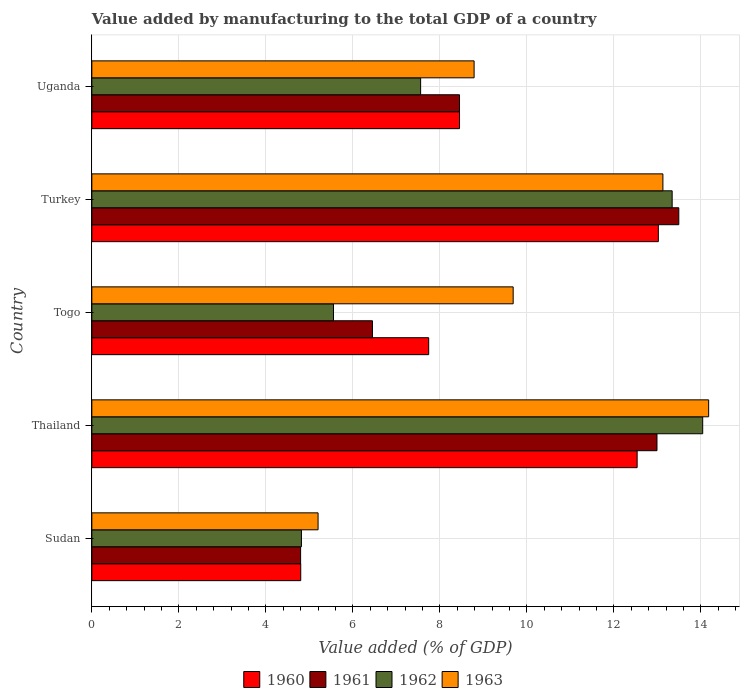How many different coloured bars are there?
Provide a succinct answer. 4. Are the number of bars per tick equal to the number of legend labels?
Your response must be concise. Yes. Are the number of bars on each tick of the Y-axis equal?
Give a very brief answer. Yes. How many bars are there on the 4th tick from the bottom?
Keep it short and to the point. 4. What is the label of the 3rd group of bars from the top?
Provide a succinct answer. Togo. In how many cases, is the number of bars for a given country not equal to the number of legend labels?
Your answer should be very brief. 0. What is the value added by manufacturing to the total GDP in 1962 in Thailand?
Your response must be concise. 14.04. Across all countries, what is the maximum value added by manufacturing to the total GDP in 1962?
Offer a very short reply. 14.04. Across all countries, what is the minimum value added by manufacturing to the total GDP in 1963?
Provide a short and direct response. 5.2. In which country was the value added by manufacturing to the total GDP in 1961 maximum?
Your answer should be very brief. Turkey. In which country was the value added by manufacturing to the total GDP in 1963 minimum?
Provide a short and direct response. Sudan. What is the total value added by manufacturing to the total GDP in 1960 in the graph?
Your response must be concise. 46.56. What is the difference between the value added by manufacturing to the total GDP in 1963 in Turkey and that in Uganda?
Provide a short and direct response. 4.34. What is the difference between the value added by manufacturing to the total GDP in 1962 in Turkey and the value added by manufacturing to the total GDP in 1963 in Uganda?
Your answer should be compact. 4.55. What is the average value added by manufacturing to the total GDP in 1963 per country?
Give a very brief answer. 10.2. What is the difference between the value added by manufacturing to the total GDP in 1961 and value added by manufacturing to the total GDP in 1963 in Thailand?
Keep it short and to the point. -1.19. In how many countries, is the value added by manufacturing to the total GDP in 1960 greater than 8 %?
Give a very brief answer. 3. What is the ratio of the value added by manufacturing to the total GDP in 1960 in Sudan to that in Uganda?
Ensure brevity in your answer.  0.57. Is the difference between the value added by manufacturing to the total GDP in 1961 in Sudan and Turkey greater than the difference between the value added by manufacturing to the total GDP in 1963 in Sudan and Turkey?
Give a very brief answer. No. What is the difference between the highest and the second highest value added by manufacturing to the total GDP in 1963?
Your answer should be very brief. 1.05. What is the difference between the highest and the lowest value added by manufacturing to the total GDP in 1963?
Provide a succinct answer. 8.98. Is it the case that in every country, the sum of the value added by manufacturing to the total GDP in 1960 and value added by manufacturing to the total GDP in 1963 is greater than the value added by manufacturing to the total GDP in 1962?
Offer a very short reply. Yes. Does the graph contain any zero values?
Ensure brevity in your answer.  No. Does the graph contain grids?
Make the answer very short. Yes. How are the legend labels stacked?
Offer a very short reply. Horizontal. What is the title of the graph?
Provide a succinct answer. Value added by manufacturing to the total GDP of a country. What is the label or title of the X-axis?
Your answer should be very brief. Value added (% of GDP). What is the Value added (% of GDP) in 1960 in Sudan?
Keep it short and to the point. 4.8. What is the Value added (% of GDP) in 1961 in Sudan?
Give a very brief answer. 4.8. What is the Value added (% of GDP) of 1962 in Sudan?
Give a very brief answer. 4.82. What is the Value added (% of GDP) of 1963 in Sudan?
Your response must be concise. 5.2. What is the Value added (% of GDP) in 1960 in Thailand?
Your answer should be compact. 12.54. What is the Value added (% of GDP) in 1961 in Thailand?
Give a very brief answer. 12.99. What is the Value added (% of GDP) of 1962 in Thailand?
Give a very brief answer. 14.04. What is the Value added (% of GDP) in 1963 in Thailand?
Keep it short and to the point. 14.18. What is the Value added (% of GDP) of 1960 in Togo?
Offer a terse response. 7.74. What is the Value added (% of GDP) in 1961 in Togo?
Provide a succinct answer. 6.45. What is the Value added (% of GDP) in 1962 in Togo?
Your response must be concise. 5.56. What is the Value added (% of GDP) in 1963 in Togo?
Your answer should be very brief. 9.69. What is the Value added (% of GDP) in 1960 in Turkey?
Offer a very short reply. 13.02. What is the Value added (% of GDP) in 1961 in Turkey?
Your answer should be very brief. 13.49. What is the Value added (% of GDP) in 1962 in Turkey?
Keep it short and to the point. 13.34. What is the Value added (% of GDP) in 1963 in Turkey?
Provide a succinct answer. 13.13. What is the Value added (% of GDP) in 1960 in Uganda?
Provide a short and direct response. 8.45. What is the Value added (% of GDP) of 1961 in Uganda?
Your response must be concise. 8.45. What is the Value added (% of GDP) in 1962 in Uganda?
Ensure brevity in your answer.  7.56. What is the Value added (% of GDP) of 1963 in Uganda?
Keep it short and to the point. 8.79. Across all countries, what is the maximum Value added (% of GDP) of 1960?
Offer a terse response. 13.02. Across all countries, what is the maximum Value added (% of GDP) of 1961?
Keep it short and to the point. 13.49. Across all countries, what is the maximum Value added (% of GDP) in 1962?
Give a very brief answer. 14.04. Across all countries, what is the maximum Value added (% of GDP) of 1963?
Provide a short and direct response. 14.18. Across all countries, what is the minimum Value added (% of GDP) of 1960?
Your response must be concise. 4.8. Across all countries, what is the minimum Value added (% of GDP) in 1961?
Keep it short and to the point. 4.8. Across all countries, what is the minimum Value added (% of GDP) of 1962?
Provide a short and direct response. 4.82. Across all countries, what is the minimum Value added (% of GDP) in 1963?
Offer a terse response. 5.2. What is the total Value added (% of GDP) in 1960 in the graph?
Keep it short and to the point. 46.56. What is the total Value added (% of GDP) of 1961 in the graph?
Your answer should be very brief. 46.19. What is the total Value added (% of GDP) of 1962 in the graph?
Your answer should be very brief. 45.32. What is the total Value added (% of GDP) of 1963 in the graph?
Your answer should be very brief. 50.99. What is the difference between the Value added (% of GDP) in 1960 in Sudan and that in Thailand?
Ensure brevity in your answer.  -7.73. What is the difference between the Value added (% of GDP) in 1961 in Sudan and that in Thailand?
Provide a succinct answer. -8.19. What is the difference between the Value added (% of GDP) in 1962 in Sudan and that in Thailand?
Make the answer very short. -9.23. What is the difference between the Value added (% of GDP) of 1963 in Sudan and that in Thailand?
Make the answer very short. -8.98. What is the difference between the Value added (% of GDP) of 1960 in Sudan and that in Togo?
Provide a short and direct response. -2.94. What is the difference between the Value added (% of GDP) in 1961 in Sudan and that in Togo?
Provide a succinct answer. -1.65. What is the difference between the Value added (% of GDP) of 1962 in Sudan and that in Togo?
Ensure brevity in your answer.  -0.74. What is the difference between the Value added (% of GDP) of 1963 in Sudan and that in Togo?
Offer a terse response. -4.49. What is the difference between the Value added (% of GDP) in 1960 in Sudan and that in Turkey?
Offer a terse response. -8.22. What is the difference between the Value added (% of GDP) of 1961 in Sudan and that in Turkey?
Your response must be concise. -8.69. What is the difference between the Value added (% of GDP) of 1962 in Sudan and that in Turkey?
Provide a short and direct response. -8.52. What is the difference between the Value added (% of GDP) in 1963 in Sudan and that in Turkey?
Provide a succinct answer. -7.93. What is the difference between the Value added (% of GDP) of 1960 in Sudan and that in Uganda?
Your response must be concise. -3.65. What is the difference between the Value added (% of GDP) of 1961 in Sudan and that in Uganda?
Give a very brief answer. -3.65. What is the difference between the Value added (% of GDP) of 1962 in Sudan and that in Uganda?
Offer a terse response. -2.74. What is the difference between the Value added (% of GDP) of 1963 in Sudan and that in Uganda?
Offer a terse response. -3.59. What is the difference between the Value added (% of GDP) of 1960 in Thailand and that in Togo?
Make the answer very short. 4.79. What is the difference between the Value added (% of GDP) in 1961 in Thailand and that in Togo?
Offer a very short reply. 6.54. What is the difference between the Value added (% of GDP) in 1962 in Thailand and that in Togo?
Ensure brevity in your answer.  8.49. What is the difference between the Value added (% of GDP) of 1963 in Thailand and that in Togo?
Your answer should be compact. 4.49. What is the difference between the Value added (% of GDP) in 1960 in Thailand and that in Turkey?
Your response must be concise. -0.49. What is the difference between the Value added (% of GDP) of 1961 in Thailand and that in Turkey?
Provide a succinct answer. -0.5. What is the difference between the Value added (% of GDP) in 1962 in Thailand and that in Turkey?
Give a very brief answer. 0.7. What is the difference between the Value added (% of GDP) in 1963 in Thailand and that in Turkey?
Provide a succinct answer. 1.05. What is the difference between the Value added (% of GDP) of 1960 in Thailand and that in Uganda?
Give a very brief answer. 4.08. What is the difference between the Value added (% of GDP) of 1961 in Thailand and that in Uganda?
Provide a succinct answer. 4.54. What is the difference between the Value added (% of GDP) of 1962 in Thailand and that in Uganda?
Keep it short and to the point. 6.49. What is the difference between the Value added (% of GDP) of 1963 in Thailand and that in Uganda?
Offer a very short reply. 5.39. What is the difference between the Value added (% of GDP) of 1960 in Togo and that in Turkey?
Your answer should be very brief. -5.28. What is the difference between the Value added (% of GDP) of 1961 in Togo and that in Turkey?
Offer a terse response. -7.04. What is the difference between the Value added (% of GDP) of 1962 in Togo and that in Turkey?
Your response must be concise. -7.79. What is the difference between the Value added (% of GDP) of 1963 in Togo and that in Turkey?
Your answer should be very brief. -3.44. What is the difference between the Value added (% of GDP) in 1960 in Togo and that in Uganda?
Make the answer very short. -0.71. What is the difference between the Value added (% of GDP) of 1961 in Togo and that in Uganda?
Offer a terse response. -2. What is the difference between the Value added (% of GDP) of 1962 in Togo and that in Uganda?
Keep it short and to the point. -2. What is the difference between the Value added (% of GDP) in 1963 in Togo and that in Uganda?
Your answer should be compact. 0.9. What is the difference between the Value added (% of GDP) of 1960 in Turkey and that in Uganda?
Keep it short and to the point. 4.57. What is the difference between the Value added (% of GDP) of 1961 in Turkey and that in Uganda?
Your answer should be compact. 5.04. What is the difference between the Value added (% of GDP) of 1962 in Turkey and that in Uganda?
Ensure brevity in your answer.  5.78. What is the difference between the Value added (% of GDP) in 1963 in Turkey and that in Uganda?
Provide a succinct answer. 4.34. What is the difference between the Value added (% of GDP) of 1960 in Sudan and the Value added (% of GDP) of 1961 in Thailand?
Offer a terse response. -8.19. What is the difference between the Value added (% of GDP) in 1960 in Sudan and the Value added (% of GDP) in 1962 in Thailand?
Offer a very short reply. -9.24. What is the difference between the Value added (% of GDP) in 1960 in Sudan and the Value added (% of GDP) in 1963 in Thailand?
Offer a very short reply. -9.38. What is the difference between the Value added (% of GDP) in 1961 in Sudan and the Value added (% of GDP) in 1962 in Thailand?
Provide a succinct answer. -9.24. What is the difference between the Value added (% of GDP) of 1961 in Sudan and the Value added (% of GDP) of 1963 in Thailand?
Provide a short and direct response. -9.38. What is the difference between the Value added (% of GDP) in 1962 in Sudan and the Value added (% of GDP) in 1963 in Thailand?
Make the answer very short. -9.36. What is the difference between the Value added (% of GDP) in 1960 in Sudan and the Value added (% of GDP) in 1961 in Togo?
Give a very brief answer. -1.65. What is the difference between the Value added (% of GDP) of 1960 in Sudan and the Value added (% of GDP) of 1962 in Togo?
Your response must be concise. -0.75. What is the difference between the Value added (% of GDP) in 1960 in Sudan and the Value added (% of GDP) in 1963 in Togo?
Provide a succinct answer. -4.88. What is the difference between the Value added (% of GDP) of 1961 in Sudan and the Value added (% of GDP) of 1962 in Togo?
Offer a very short reply. -0.76. What is the difference between the Value added (% of GDP) of 1961 in Sudan and the Value added (% of GDP) of 1963 in Togo?
Give a very brief answer. -4.89. What is the difference between the Value added (% of GDP) of 1962 in Sudan and the Value added (% of GDP) of 1963 in Togo?
Ensure brevity in your answer.  -4.87. What is the difference between the Value added (% of GDP) of 1960 in Sudan and the Value added (% of GDP) of 1961 in Turkey?
Your response must be concise. -8.69. What is the difference between the Value added (% of GDP) of 1960 in Sudan and the Value added (% of GDP) of 1962 in Turkey?
Ensure brevity in your answer.  -8.54. What is the difference between the Value added (% of GDP) in 1960 in Sudan and the Value added (% of GDP) in 1963 in Turkey?
Make the answer very short. -8.33. What is the difference between the Value added (% of GDP) of 1961 in Sudan and the Value added (% of GDP) of 1962 in Turkey?
Your response must be concise. -8.54. What is the difference between the Value added (% of GDP) in 1961 in Sudan and the Value added (% of GDP) in 1963 in Turkey?
Make the answer very short. -8.33. What is the difference between the Value added (% of GDP) of 1962 in Sudan and the Value added (% of GDP) of 1963 in Turkey?
Your answer should be compact. -8.31. What is the difference between the Value added (% of GDP) of 1960 in Sudan and the Value added (% of GDP) of 1961 in Uganda?
Give a very brief answer. -3.65. What is the difference between the Value added (% of GDP) in 1960 in Sudan and the Value added (% of GDP) in 1962 in Uganda?
Offer a very short reply. -2.76. What is the difference between the Value added (% of GDP) in 1960 in Sudan and the Value added (% of GDP) in 1963 in Uganda?
Your answer should be compact. -3.99. What is the difference between the Value added (% of GDP) of 1961 in Sudan and the Value added (% of GDP) of 1962 in Uganda?
Offer a very short reply. -2.76. What is the difference between the Value added (% of GDP) of 1961 in Sudan and the Value added (% of GDP) of 1963 in Uganda?
Make the answer very short. -3.99. What is the difference between the Value added (% of GDP) of 1962 in Sudan and the Value added (% of GDP) of 1963 in Uganda?
Provide a short and direct response. -3.97. What is the difference between the Value added (% of GDP) of 1960 in Thailand and the Value added (% of GDP) of 1961 in Togo?
Provide a short and direct response. 6.09. What is the difference between the Value added (% of GDP) in 1960 in Thailand and the Value added (% of GDP) in 1962 in Togo?
Provide a short and direct response. 6.98. What is the difference between the Value added (% of GDP) of 1960 in Thailand and the Value added (% of GDP) of 1963 in Togo?
Ensure brevity in your answer.  2.85. What is the difference between the Value added (% of GDP) in 1961 in Thailand and the Value added (% of GDP) in 1962 in Togo?
Offer a terse response. 7.44. What is the difference between the Value added (% of GDP) of 1961 in Thailand and the Value added (% of GDP) of 1963 in Togo?
Ensure brevity in your answer.  3.31. What is the difference between the Value added (% of GDP) in 1962 in Thailand and the Value added (% of GDP) in 1963 in Togo?
Offer a very short reply. 4.36. What is the difference between the Value added (% of GDP) in 1960 in Thailand and the Value added (% of GDP) in 1961 in Turkey?
Offer a very short reply. -0.96. What is the difference between the Value added (% of GDP) of 1960 in Thailand and the Value added (% of GDP) of 1962 in Turkey?
Provide a succinct answer. -0.81. What is the difference between the Value added (% of GDP) in 1960 in Thailand and the Value added (% of GDP) in 1963 in Turkey?
Provide a succinct answer. -0.59. What is the difference between the Value added (% of GDP) in 1961 in Thailand and the Value added (% of GDP) in 1962 in Turkey?
Keep it short and to the point. -0.35. What is the difference between the Value added (% of GDP) of 1961 in Thailand and the Value added (% of GDP) of 1963 in Turkey?
Make the answer very short. -0.14. What is the difference between the Value added (% of GDP) in 1962 in Thailand and the Value added (% of GDP) in 1963 in Turkey?
Offer a very short reply. 0.92. What is the difference between the Value added (% of GDP) of 1960 in Thailand and the Value added (% of GDP) of 1961 in Uganda?
Make the answer very short. 4.08. What is the difference between the Value added (% of GDP) of 1960 in Thailand and the Value added (% of GDP) of 1962 in Uganda?
Keep it short and to the point. 4.98. What is the difference between the Value added (% of GDP) of 1960 in Thailand and the Value added (% of GDP) of 1963 in Uganda?
Provide a short and direct response. 3.75. What is the difference between the Value added (% of GDP) of 1961 in Thailand and the Value added (% of GDP) of 1962 in Uganda?
Offer a terse response. 5.43. What is the difference between the Value added (% of GDP) in 1961 in Thailand and the Value added (% of GDP) in 1963 in Uganda?
Give a very brief answer. 4.2. What is the difference between the Value added (% of GDP) of 1962 in Thailand and the Value added (% of GDP) of 1963 in Uganda?
Your answer should be compact. 5.26. What is the difference between the Value added (% of GDP) of 1960 in Togo and the Value added (% of GDP) of 1961 in Turkey?
Provide a succinct answer. -5.75. What is the difference between the Value added (% of GDP) in 1960 in Togo and the Value added (% of GDP) in 1962 in Turkey?
Offer a very short reply. -5.6. What is the difference between the Value added (% of GDP) of 1960 in Togo and the Value added (% of GDP) of 1963 in Turkey?
Give a very brief answer. -5.38. What is the difference between the Value added (% of GDP) of 1961 in Togo and the Value added (% of GDP) of 1962 in Turkey?
Offer a very short reply. -6.89. What is the difference between the Value added (% of GDP) in 1961 in Togo and the Value added (% of GDP) in 1963 in Turkey?
Provide a short and direct response. -6.68. What is the difference between the Value added (% of GDP) of 1962 in Togo and the Value added (% of GDP) of 1963 in Turkey?
Keep it short and to the point. -7.57. What is the difference between the Value added (% of GDP) in 1960 in Togo and the Value added (% of GDP) in 1961 in Uganda?
Your answer should be very brief. -0.71. What is the difference between the Value added (% of GDP) of 1960 in Togo and the Value added (% of GDP) of 1962 in Uganda?
Your response must be concise. 0.19. What is the difference between the Value added (% of GDP) of 1960 in Togo and the Value added (% of GDP) of 1963 in Uganda?
Ensure brevity in your answer.  -1.04. What is the difference between the Value added (% of GDP) of 1961 in Togo and the Value added (% of GDP) of 1962 in Uganda?
Give a very brief answer. -1.11. What is the difference between the Value added (% of GDP) of 1961 in Togo and the Value added (% of GDP) of 1963 in Uganda?
Provide a short and direct response. -2.34. What is the difference between the Value added (% of GDP) of 1962 in Togo and the Value added (% of GDP) of 1963 in Uganda?
Make the answer very short. -3.23. What is the difference between the Value added (% of GDP) in 1960 in Turkey and the Value added (% of GDP) in 1961 in Uganda?
Your response must be concise. 4.57. What is the difference between the Value added (% of GDP) in 1960 in Turkey and the Value added (% of GDP) in 1962 in Uganda?
Keep it short and to the point. 5.47. What is the difference between the Value added (% of GDP) of 1960 in Turkey and the Value added (% of GDP) of 1963 in Uganda?
Offer a very short reply. 4.24. What is the difference between the Value added (% of GDP) in 1961 in Turkey and the Value added (% of GDP) in 1962 in Uganda?
Keep it short and to the point. 5.94. What is the difference between the Value added (% of GDP) of 1961 in Turkey and the Value added (% of GDP) of 1963 in Uganda?
Ensure brevity in your answer.  4.71. What is the difference between the Value added (% of GDP) of 1962 in Turkey and the Value added (% of GDP) of 1963 in Uganda?
Offer a terse response. 4.55. What is the average Value added (% of GDP) of 1960 per country?
Your answer should be very brief. 9.31. What is the average Value added (% of GDP) of 1961 per country?
Provide a short and direct response. 9.24. What is the average Value added (% of GDP) of 1962 per country?
Offer a terse response. 9.06. What is the average Value added (% of GDP) of 1963 per country?
Ensure brevity in your answer.  10.2. What is the difference between the Value added (% of GDP) in 1960 and Value added (% of GDP) in 1961 in Sudan?
Make the answer very short. 0. What is the difference between the Value added (% of GDP) in 1960 and Value added (% of GDP) in 1962 in Sudan?
Offer a very short reply. -0.02. What is the difference between the Value added (% of GDP) of 1960 and Value added (% of GDP) of 1963 in Sudan?
Make the answer very short. -0.4. What is the difference between the Value added (% of GDP) in 1961 and Value added (% of GDP) in 1962 in Sudan?
Keep it short and to the point. -0.02. What is the difference between the Value added (% of GDP) in 1961 and Value added (% of GDP) in 1963 in Sudan?
Make the answer very short. -0.4. What is the difference between the Value added (% of GDP) of 1962 and Value added (% of GDP) of 1963 in Sudan?
Provide a short and direct response. -0.38. What is the difference between the Value added (% of GDP) in 1960 and Value added (% of GDP) in 1961 in Thailand?
Offer a very short reply. -0.46. What is the difference between the Value added (% of GDP) of 1960 and Value added (% of GDP) of 1962 in Thailand?
Give a very brief answer. -1.51. What is the difference between the Value added (% of GDP) of 1960 and Value added (% of GDP) of 1963 in Thailand?
Your response must be concise. -1.64. What is the difference between the Value added (% of GDP) of 1961 and Value added (% of GDP) of 1962 in Thailand?
Offer a very short reply. -1.05. What is the difference between the Value added (% of GDP) of 1961 and Value added (% of GDP) of 1963 in Thailand?
Keep it short and to the point. -1.19. What is the difference between the Value added (% of GDP) in 1962 and Value added (% of GDP) in 1963 in Thailand?
Keep it short and to the point. -0.14. What is the difference between the Value added (% of GDP) in 1960 and Value added (% of GDP) in 1961 in Togo?
Your response must be concise. 1.29. What is the difference between the Value added (% of GDP) in 1960 and Value added (% of GDP) in 1962 in Togo?
Your answer should be very brief. 2.19. What is the difference between the Value added (% of GDP) in 1960 and Value added (% of GDP) in 1963 in Togo?
Make the answer very short. -1.94. What is the difference between the Value added (% of GDP) in 1961 and Value added (% of GDP) in 1962 in Togo?
Make the answer very short. 0.9. What is the difference between the Value added (% of GDP) of 1961 and Value added (% of GDP) of 1963 in Togo?
Ensure brevity in your answer.  -3.23. What is the difference between the Value added (% of GDP) in 1962 and Value added (% of GDP) in 1963 in Togo?
Your answer should be compact. -4.13. What is the difference between the Value added (% of GDP) in 1960 and Value added (% of GDP) in 1961 in Turkey?
Your answer should be very brief. -0.47. What is the difference between the Value added (% of GDP) of 1960 and Value added (% of GDP) of 1962 in Turkey?
Ensure brevity in your answer.  -0.32. What is the difference between the Value added (% of GDP) of 1960 and Value added (% of GDP) of 1963 in Turkey?
Your answer should be very brief. -0.11. What is the difference between the Value added (% of GDP) in 1961 and Value added (% of GDP) in 1962 in Turkey?
Your response must be concise. 0.15. What is the difference between the Value added (% of GDP) in 1961 and Value added (% of GDP) in 1963 in Turkey?
Ensure brevity in your answer.  0.37. What is the difference between the Value added (% of GDP) in 1962 and Value added (% of GDP) in 1963 in Turkey?
Keep it short and to the point. 0.21. What is the difference between the Value added (% of GDP) of 1960 and Value added (% of GDP) of 1961 in Uganda?
Offer a very short reply. -0. What is the difference between the Value added (% of GDP) in 1960 and Value added (% of GDP) in 1962 in Uganda?
Offer a terse response. 0.89. What is the difference between the Value added (% of GDP) of 1960 and Value added (% of GDP) of 1963 in Uganda?
Ensure brevity in your answer.  -0.34. What is the difference between the Value added (% of GDP) of 1961 and Value added (% of GDP) of 1962 in Uganda?
Offer a terse response. 0.89. What is the difference between the Value added (% of GDP) in 1961 and Value added (% of GDP) in 1963 in Uganda?
Your answer should be compact. -0.34. What is the difference between the Value added (% of GDP) of 1962 and Value added (% of GDP) of 1963 in Uganda?
Your answer should be compact. -1.23. What is the ratio of the Value added (% of GDP) in 1960 in Sudan to that in Thailand?
Give a very brief answer. 0.38. What is the ratio of the Value added (% of GDP) in 1961 in Sudan to that in Thailand?
Give a very brief answer. 0.37. What is the ratio of the Value added (% of GDP) of 1962 in Sudan to that in Thailand?
Provide a succinct answer. 0.34. What is the ratio of the Value added (% of GDP) in 1963 in Sudan to that in Thailand?
Your response must be concise. 0.37. What is the ratio of the Value added (% of GDP) in 1960 in Sudan to that in Togo?
Keep it short and to the point. 0.62. What is the ratio of the Value added (% of GDP) in 1961 in Sudan to that in Togo?
Keep it short and to the point. 0.74. What is the ratio of the Value added (% of GDP) of 1962 in Sudan to that in Togo?
Give a very brief answer. 0.87. What is the ratio of the Value added (% of GDP) of 1963 in Sudan to that in Togo?
Offer a terse response. 0.54. What is the ratio of the Value added (% of GDP) of 1960 in Sudan to that in Turkey?
Make the answer very short. 0.37. What is the ratio of the Value added (% of GDP) of 1961 in Sudan to that in Turkey?
Your answer should be very brief. 0.36. What is the ratio of the Value added (% of GDP) in 1962 in Sudan to that in Turkey?
Your answer should be very brief. 0.36. What is the ratio of the Value added (% of GDP) in 1963 in Sudan to that in Turkey?
Keep it short and to the point. 0.4. What is the ratio of the Value added (% of GDP) of 1960 in Sudan to that in Uganda?
Offer a very short reply. 0.57. What is the ratio of the Value added (% of GDP) in 1961 in Sudan to that in Uganda?
Keep it short and to the point. 0.57. What is the ratio of the Value added (% of GDP) in 1962 in Sudan to that in Uganda?
Offer a very short reply. 0.64. What is the ratio of the Value added (% of GDP) of 1963 in Sudan to that in Uganda?
Your response must be concise. 0.59. What is the ratio of the Value added (% of GDP) in 1960 in Thailand to that in Togo?
Provide a succinct answer. 1.62. What is the ratio of the Value added (% of GDP) of 1961 in Thailand to that in Togo?
Make the answer very short. 2.01. What is the ratio of the Value added (% of GDP) in 1962 in Thailand to that in Togo?
Ensure brevity in your answer.  2.53. What is the ratio of the Value added (% of GDP) in 1963 in Thailand to that in Togo?
Provide a short and direct response. 1.46. What is the ratio of the Value added (% of GDP) in 1960 in Thailand to that in Turkey?
Your answer should be compact. 0.96. What is the ratio of the Value added (% of GDP) in 1961 in Thailand to that in Turkey?
Make the answer very short. 0.96. What is the ratio of the Value added (% of GDP) of 1962 in Thailand to that in Turkey?
Offer a very short reply. 1.05. What is the ratio of the Value added (% of GDP) of 1963 in Thailand to that in Turkey?
Make the answer very short. 1.08. What is the ratio of the Value added (% of GDP) in 1960 in Thailand to that in Uganda?
Provide a succinct answer. 1.48. What is the ratio of the Value added (% of GDP) of 1961 in Thailand to that in Uganda?
Your response must be concise. 1.54. What is the ratio of the Value added (% of GDP) of 1962 in Thailand to that in Uganda?
Give a very brief answer. 1.86. What is the ratio of the Value added (% of GDP) of 1963 in Thailand to that in Uganda?
Offer a very short reply. 1.61. What is the ratio of the Value added (% of GDP) of 1960 in Togo to that in Turkey?
Offer a very short reply. 0.59. What is the ratio of the Value added (% of GDP) of 1961 in Togo to that in Turkey?
Offer a terse response. 0.48. What is the ratio of the Value added (% of GDP) in 1962 in Togo to that in Turkey?
Give a very brief answer. 0.42. What is the ratio of the Value added (% of GDP) in 1963 in Togo to that in Turkey?
Provide a short and direct response. 0.74. What is the ratio of the Value added (% of GDP) in 1960 in Togo to that in Uganda?
Make the answer very short. 0.92. What is the ratio of the Value added (% of GDP) of 1961 in Togo to that in Uganda?
Offer a terse response. 0.76. What is the ratio of the Value added (% of GDP) in 1962 in Togo to that in Uganda?
Offer a terse response. 0.73. What is the ratio of the Value added (% of GDP) of 1963 in Togo to that in Uganda?
Your answer should be compact. 1.1. What is the ratio of the Value added (% of GDP) of 1960 in Turkey to that in Uganda?
Ensure brevity in your answer.  1.54. What is the ratio of the Value added (% of GDP) in 1961 in Turkey to that in Uganda?
Offer a very short reply. 1.6. What is the ratio of the Value added (% of GDP) in 1962 in Turkey to that in Uganda?
Provide a short and direct response. 1.77. What is the ratio of the Value added (% of GDP) in 1963 in Turkey to that in Uganda?
Offer a very short reply. 1.49. What is the difference between the highest and the second highest Value added (% of GDP) of 1960?
Ensure brevity in your answer.  0.49. What is the difference between the highest and the second highest Value added (% of GDP) of 1961?
Your answer should be compact. 0.5. What is the difference between the highest and the second highest Value added (% of GDP) of 1962?
Ensure brevity in your answer.  0.7. What is the difference between the highest and the second highest Value added (% of GDP) of 1963?
Ensure brevity in your answer.  1.05. What is the difference between the highest and the lowest Value added (% of GDP) of 1960?
Ensure brevity in your answer.  8.22. What is the difference between the highest and the lowest Value added (% of GDP) in 1961?
Ensure brevity in your answer.  8.69. What is the difference between the highest and the lowest Value added (% of GDP) in 1962?
Offer a very short reply. 9.23. What is the difference between the highest and the lowest Value added (% of GDP) of 1963?
Your answer should be very brief. 8.98. 